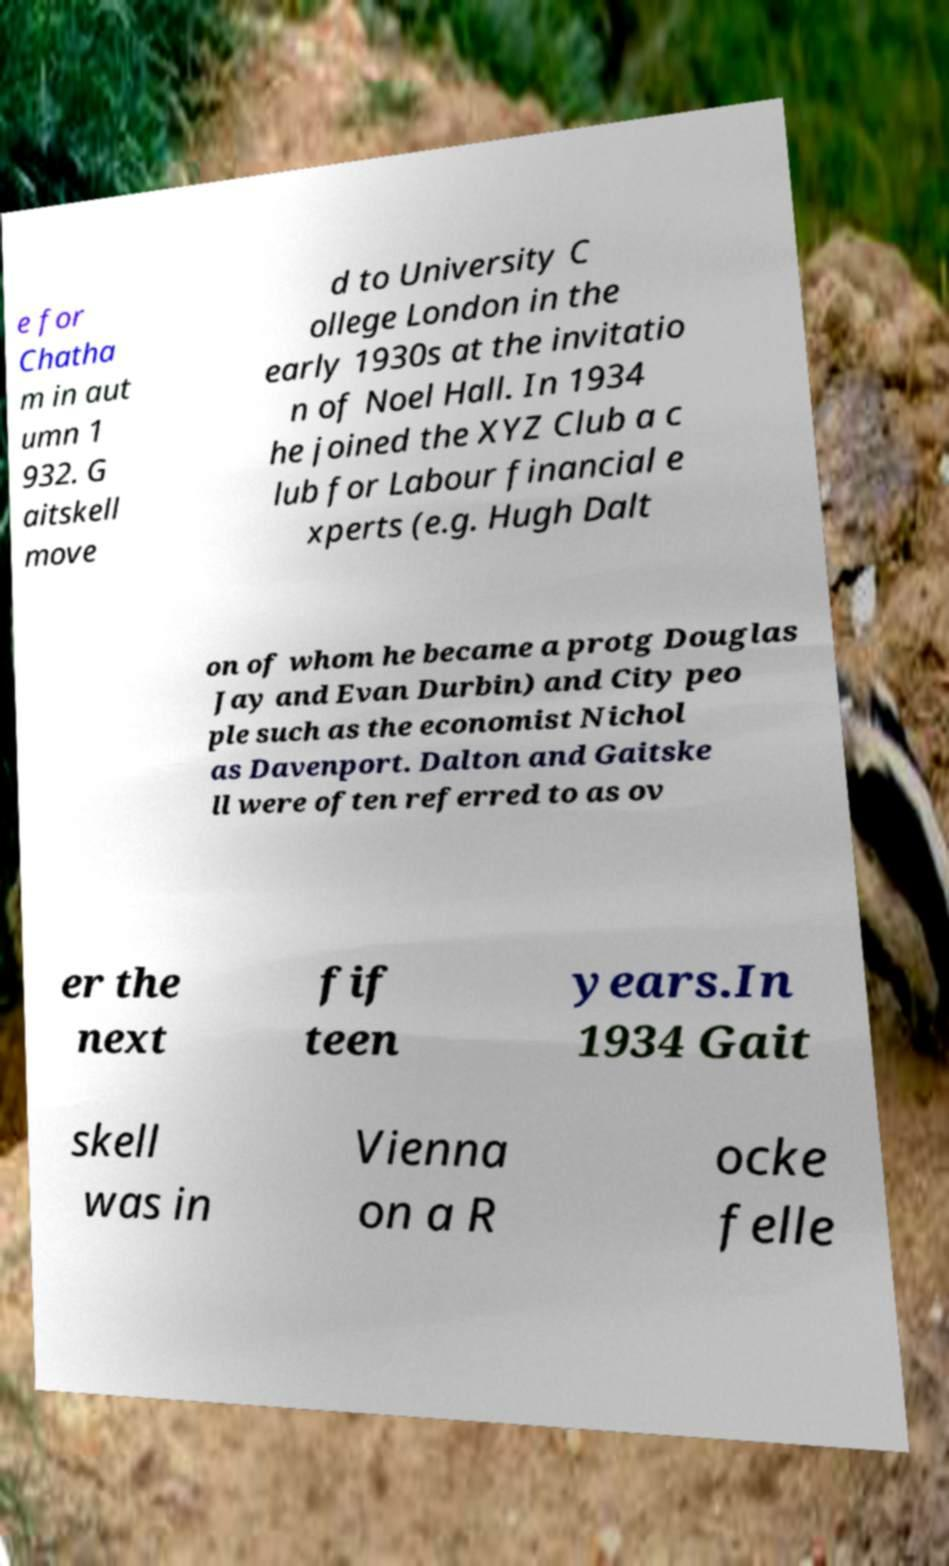There's text embedded in this image that I need extracted. Can you transcribe it verbatim? e for Chatha m in aut umn 1 932. G aitskell move d to University C ollege London in the early 1930s at the invitatio n of Noel Hall. In 1934 he joined the XYZ Club a c lub for Labour financial e xperts (e.g. Hugh Dalt on of whom he became a protg Douglas Jay and Evan Durbin) and City peo ple such as the economist Nichol as Davenport. Dalton and Gaitske ll were often referred to as ov er the next fif teen years.In 1934 Gait skell was in Vienna on a R ocke felle 